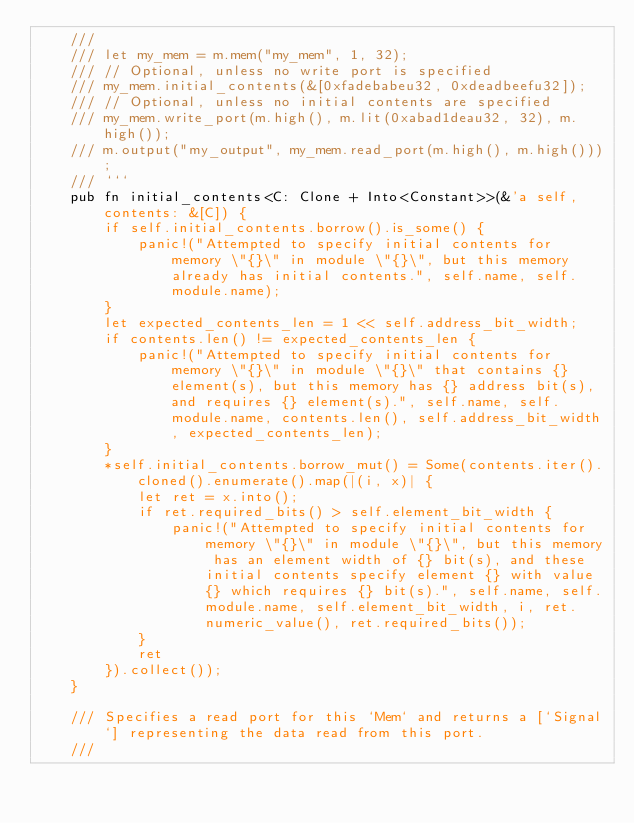Convert code to text. <code><loc_0><loc_0><loc_500><loc_500><_Rust_>    ///
    /// let my_mem = m.mem("my_mem", 1, 32);
    /// // Optional, unless no write port is specified
    /// my_mem.initial_contents(&[0xfadebabeu32, 0xdeadbeefu32]);
    /// // Optional, unless no initial contents are specified
    /// my_mem.write_port(m.high(), m.lit(0xabad1deau32, 32), m.high());
    /// m.output("my_output", my_mem.read_port(m.high(), m.high()));
    /// ```
    pub fn initial_contents<C: Clone + Into<Constant>>(&'a self, contents: &[C]) {
        if self.initial_contents.borrow().is_some() {
            panic!("Attempted to specify initial contents for memory \"{}\" in module \"{}\", but this memory already has initial contents.", self.name, self.module.name);
        }
        let expected_contents_len = 1 << self.address_bit_width;
        if contents.len() != expected_contents_len {
            panic!("Attempted to specify initial contents for memory \"{}\" in module \"{}\" that contains {} element(s), but this memory has {} address bit(s), and requires {} element(s).", self.name, self.module.name, contents.len(), self.address_bit_width, expected_contents_len);
        }
        *self.initial_contents.borrow_mut() = Some(contents.iter().cloned().enumerate().map(|(i, x)| {
            let ret = x.into();
            if ret.required_bits() > self.element_bit_width {
                panic!("Attempted to specify initial contents for memory \"{}\" in module \"{}\", but this memory has an element width of {} bit(s), and these initial contents specify element {} with value {} which requires {} bit(s).", self.name, self.module.name, self.element_bit_width, i, ret.numeric_value(), ret.required_bits());
            }
            ret
        }).collect());
    }

    /// Specifies a read port for this `Mem` and returns a [`Signal`] representing the data read from this port.
    ///</code> 